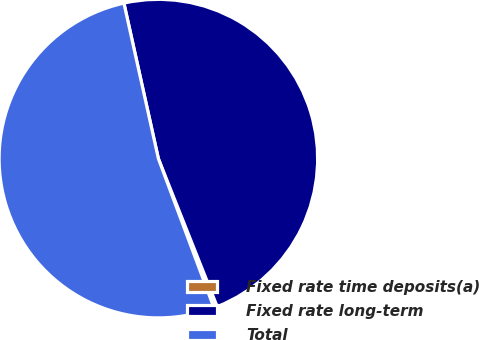Convert chart. <chart><loc_0><loc_0><loc_500><loc_500><pie_chart><fcel>Fixed rate time deposits(a)<fcel>Fixed rate long-term<fcel>Total<nl><fcel>0.35%<fcel>47.45%<fcel>52.2%<nl></chart> 